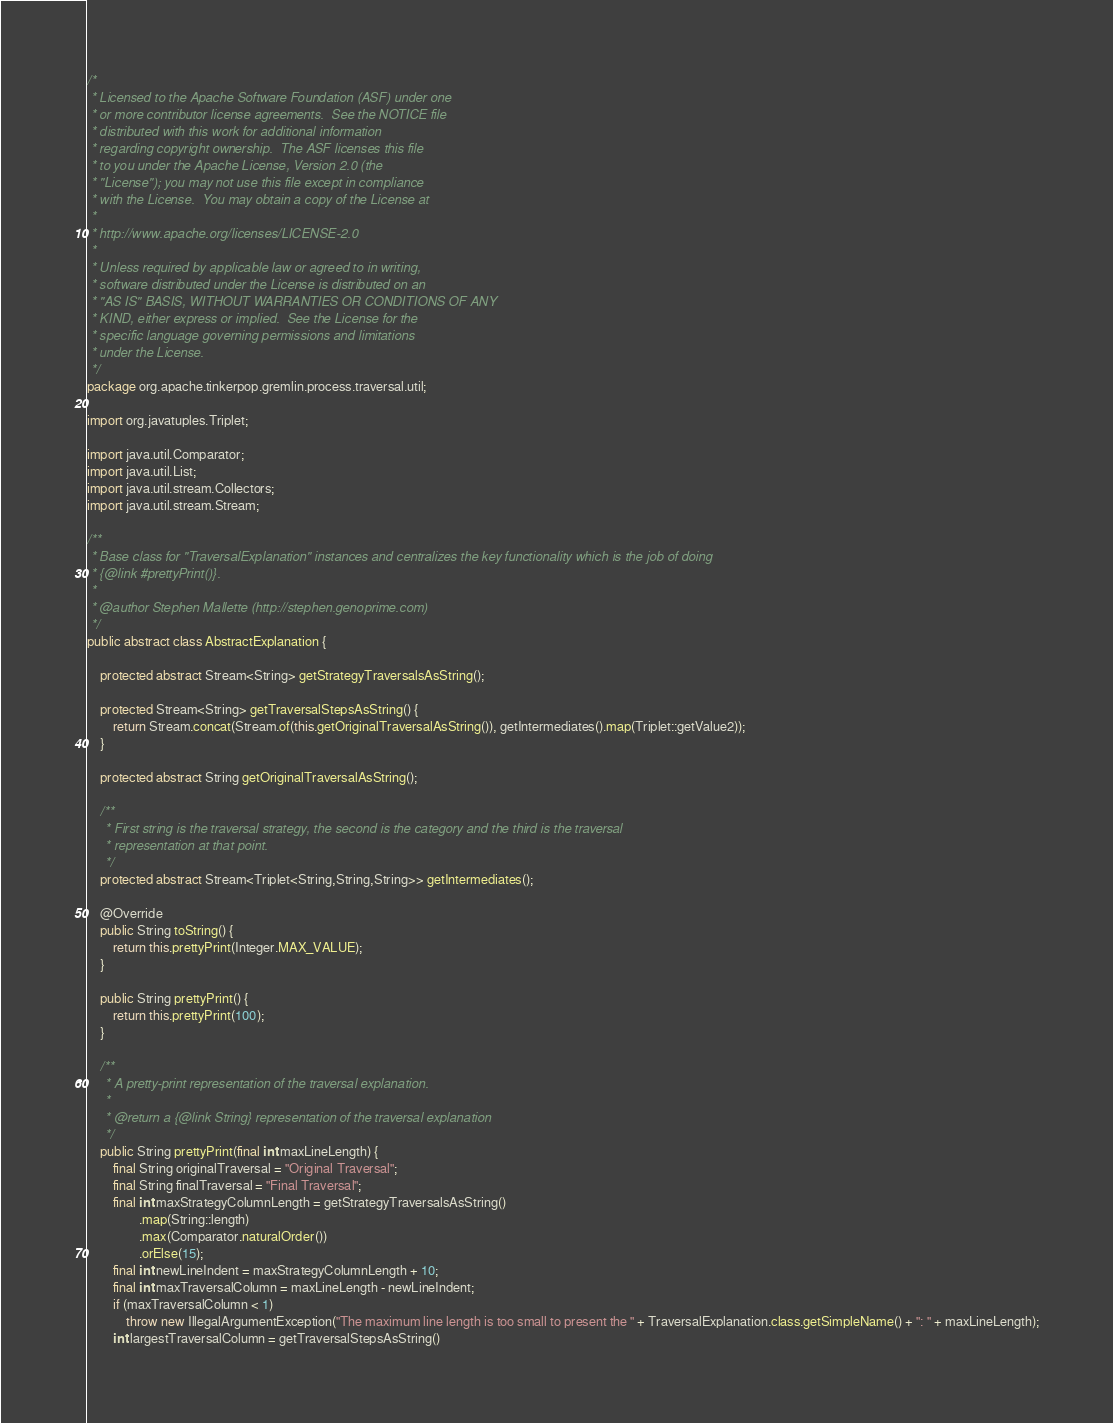Convert code to text. <code><loc_0><loc_0><loc_500><loc_500><_Java_>/*
 * Licensed to the Apache Software Foundation (ASF) under one
 * or more contributor license agreements.  See the NOTICE file
 * distributed with this work for additional information
 * regarding copyright ownership.  The ASF licenses this file
 * to you under the Apache License, Version 2.0 (the
 * "License"); you may not use this file except in compliance
 * with the License.  You may obtain a copy of the License at
 *
 * http://www.apache.org/licenses/LICENSE-2.0
 *
 * Unless required by applicable law or agreed to in writing,
 * software distributed under the License is distributed on an
 * "AS IS" BASIS, WITHOUT WARRANTIES OR CONDITIONS OF ANY
 * KIND, either express or implied.  See the License for the
 * specific language governing permissions and limitations
 * under the License.
 */
package org.apache.tinkerpop.gremlin.process.traversal.util;

import org.javatuples.Triplet;

import java.util.Comparator;
import java.util.List;
import java.util.stream.Collectors;
import java.util.stream.Stream;

/**
 * Base class for "TraversalExplanation" instances and centralizes the key functionality which is the job of doing
 * {@link #prettyPrint()}.
 * 
 * @author Stephen Mallette (http://stephen.genoprime.com)
 */
public abstract class AbstractExplanation {

    protected abstract Stream<String> getStrategyTraversalsAsString();

    protected Stream<String> getTraversalStepsAsString() {
        return Stream.concat(Stream.of(this.getOriginalTraversalAsString()), getIntermediates().map(Triplet::getValue2));
    }

    protected abstract String getOriginalTraversalAsString();

    /**
     * First string is the traversal strategy, the second is the category and the third is the traversal
     * representation at that point.
     */
    protected abstract Stream<Triplet<String,String,String>> getIntermediates();

    @Override
    public String toString() {
        return this.prettyPrint(Integer.MAX_VALUE);
    }

    public String prettyPrint() {
        return this.prettyPrint(100);
    }

    /**
     * A pretty-print representation of the traversal explanation.
     *
     * @return a {@link String} representation of the traversal explanation
     */
    public String prettyPrint(final int maxLineLength) {
        final String originalTraversal = "Original Traversal";
        final String finalTraversal = "Final Traversal";
        final int maxStrategyColumnLength = getStrategyTraversalsAsString()
                .map(String::length)
                .max(Comparator.naturalOrder())
                .orElse(15);
        final int newLineIndent = maxStrategyColumnLength + 10;
        final int maxTraversalColumn = maxLineLength - newLineIndent;
        if (maxTraversalColumn < 1)
            throw new IllegalArgumentException("The maximum line length is too small to present the " + TraversalExplanation.class.getSimpleName() + ": " + maxLineLength);
        int largestTraversalColumn = getTraversalStepsAsString()</code> 